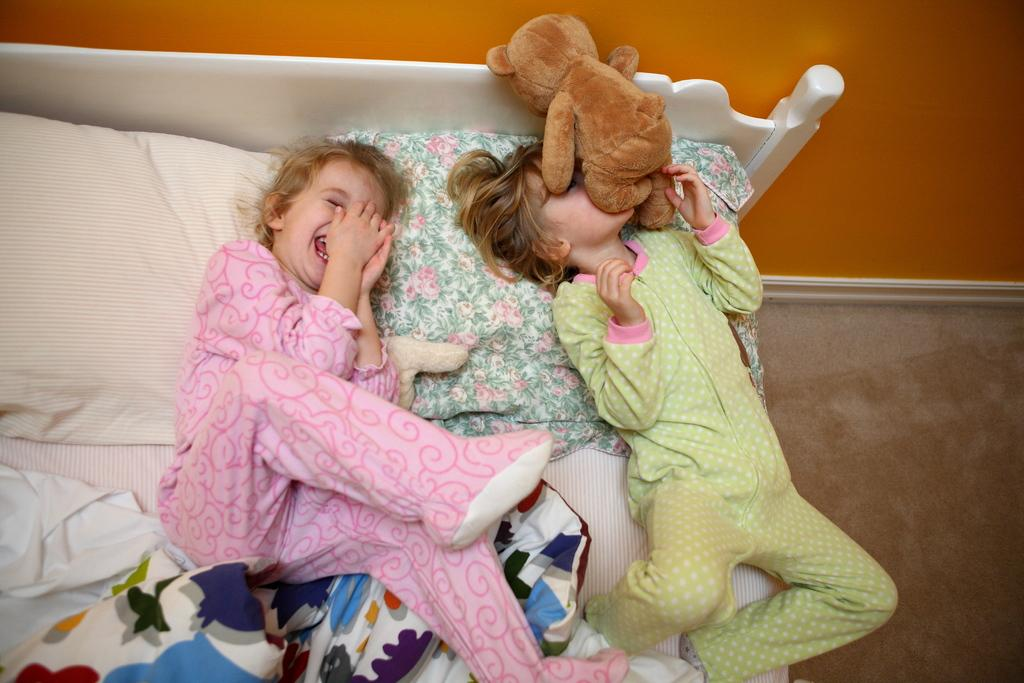How many children are in the image? There are two children in the image. What are the children doing in the image? The children are playing on the bed. Can you describe anything be seen on one of the children's faces? Yes, there is a teddy bear on one child's face. What can be seen in the background of the image? There is a wall and a floor visible in the image. What type of chairs are visible in the image? There are no chairs present in the image. What meal is being prepared on the boat in the image? There is no boat or meal preparation in the image; it features two children playing on a bed. 